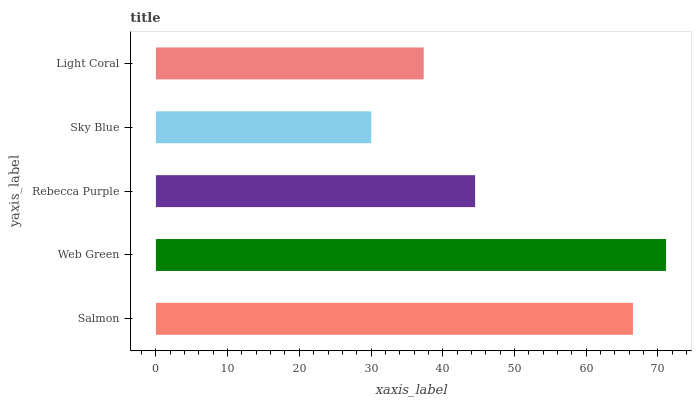Is Sky Blue the minimum?
Answer yes or no. Yes. Is Web Green the maximum?
Answer yes or no. Yes. Is Rebecca Purple the minimum?
Answer yes or no. No. Is Rebecca Purple the maximum?
Answer yes or no. No. Is Web Green greater than Rebecca Purple?
Answer yes or no. Yes. Is Rebecca Purple less than Web Green?
Answer yes or no. Yes. Is Rebecca Purple greater than Web Green?
Answer yes or no. No. Is Web Green less than Rebecca Purple?
Answer yes or no. No. Is Rebecca Purple the high median?
Answer yes or no. Yes. Is Rebecca Purple the low median?
Answer yes or no. Yes. Is Web Green the high median?
Answer yes or no. No. Is Web Green the low median?
Answer yes or no. No. 